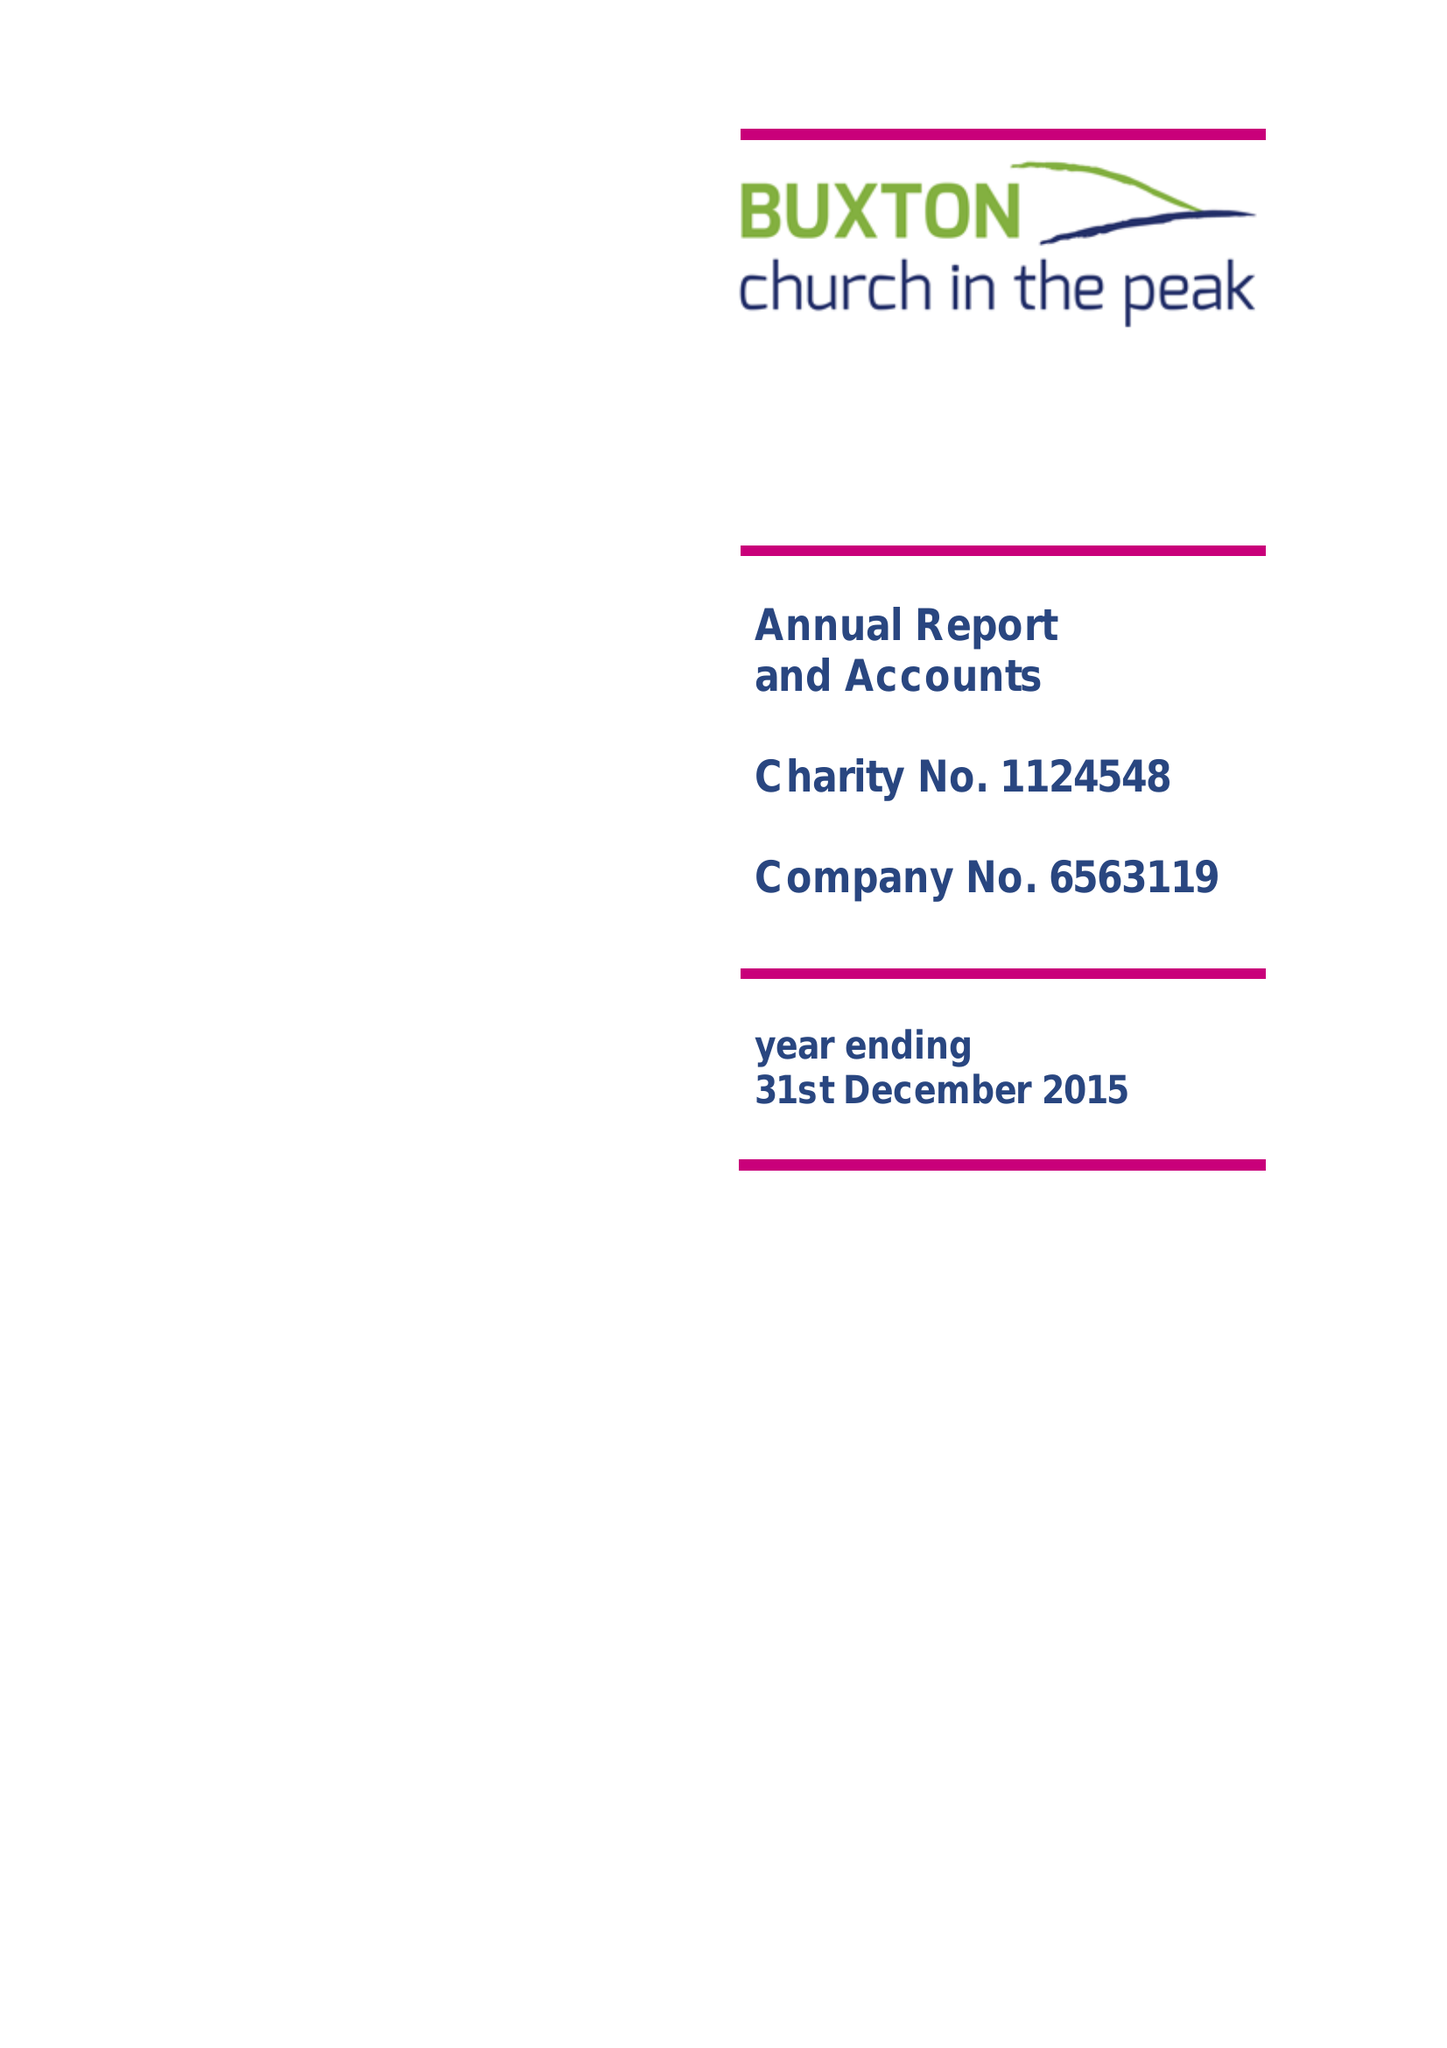What is the value for the charity_number?
Answer the question using a single word or phrase. 1124548 